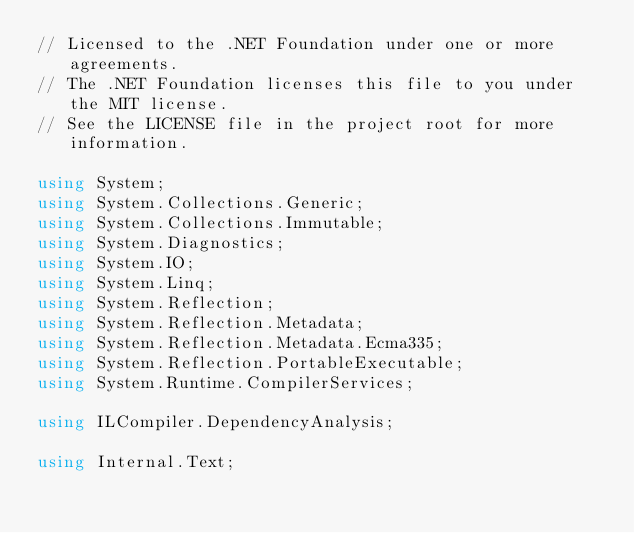<code> <loc_0><loc_0><loc_500><loc_500><_C#_>// Licensed to the .NET Foundation under one or more agreements.
// The .NET Foundation licenses this file to you under the MIT license.
// See the LICENSE file in the project root for more information.

using System;
using System.Collections.Generic;
using System.Collections.Immutable;
using System.Diagnostics;
using System.IO;
using System.Linq;
using System.Reflection;
using System.Reflection.Metadata;
using System.Reflection.Metadata.Ecma335;
using System.Reflection.PortableExecutable;
using System.Runtime.CompilerServices;

using ILCompiler.DependencyAnalysis;

using Internal.Text;</code> 